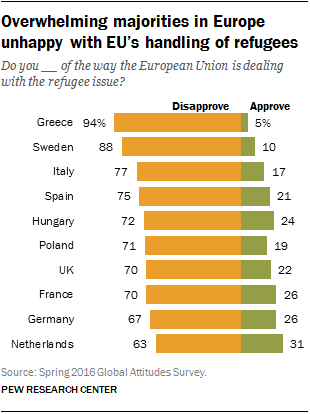Mention a couple of crucial points in this snapshot. The approval rate in Greece is 5%. There are four countries that have an approval rate of over 23%. 